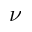<formula> <loc_0><loc_0><loc_500><loc_500>\nu</formula> 